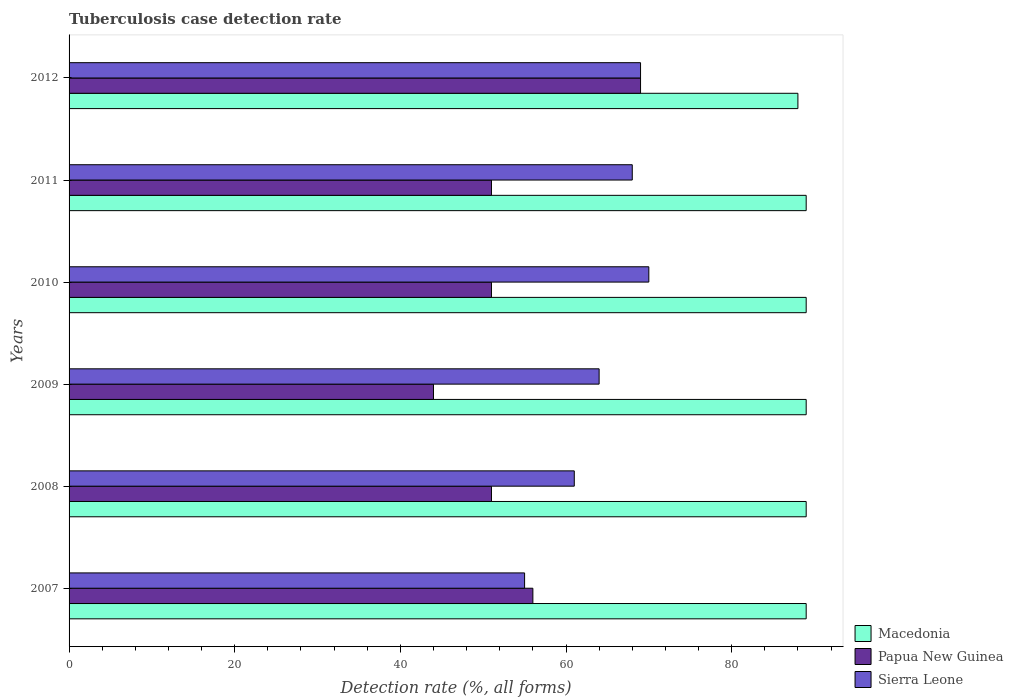Are the number of bars on each tick of the Y-axis equal?
Make the answer very short. Yes. How many bars are there on the 6th tick from the top?
Offer a terse response. 3. How many bars are there on the 2nd tick from the bottom?
Provide a succinct answer. 3. In how many cases, is the number of bars for a given year not equal to the number of legend labels?
Keep it short and to the point. 0. What is the tuberculosis case detection rate in in Sierra Leone in 2011?
Offer a very short reply. 68. Across all years, what is the maximum tuberculosis case detection rate in in Macedonia?
Ensure brevity in your answer.  89. In which year was the tuberculosis case detection rate in in Papua New Guinea maximum?
Offer a terse response. 2012. In which year was the tuberculosis case detection rate in in Papua New Guinea minimum?
Give a very brief answer. 2009. What is the total tuberculosis case detection rate in in Sierra Leone in the graph?
Provide a succinct answer. 387. What is the difference between the tuberculosis case detection rate in in Macedonia in 2007 and that in 2008?
Offer a very short reply. 0. What is the difference between the tuberculosis case detection rate in in Papua New Guinea in 2007 and the tuberculosis case detection rate in in Macedonia in 2012?
Ensure brevity in your answer.  -32. What is the average tuberculosis case detection rate in in Macedonia per year?
Give a very brief answer. 88.83. In the year 2008, what is the difference between the tuberculosis case detection rate in in Sierra Leone and tuberculosis case detection rate in in Macedonia?
Provide a succinct answer. -28. What is the ratio of the tuberculosis case detection rate in in Papua New Guinea in 2009 to that in 2011?
Provide a short and direct response. 0.86. Is the tuberculosis case detection rate in in Sierra Leone in 2008 less than that in 2011?
Provide a succinct answer. Yes. What is the difference between the highest and the lowest tuberculosis case detection rate in in Macedonia?
Provide a short and direct response. 1. In how many years, is the tuberculosis case detection rate in in Papua New Guinea greater than the average tuberculosis case detection rate in in Papua New Guinea taken over all years?
Keep it short and to the point. 2. What does the 3rd bar from the top in 2007 represents?
Make the answer very short. Macedonia. What does the 2nd bar from the bottom in 2011 represents?
Provide a short and direct response. Papua New Guinea. Is it the case that in every year, the sum of the tuberculosis case detection rate in in Macedonia and tuberculosis case detection rate in in Papua New Guinea is greater than the tuberculosis case detection rate in in Sierra Leone?
Your response must be concise. Yes. How many bars are there?
Give a very brief answer. 18. Are all the bars in the graph horizontal?
Your answer should be very brief. Yes. How many years are there in the graph?
Offer a very short reply. 6. What is the difference between two consecutive major ticks on the X-axis?
Your answer should be very brief. 20. Are the values on the major ticks of X-axis written in scientific E-notation?
Make the answer very short. No. How many legend labels are there?
Your answer should be compact. 3. How are the legend labels stacked?
Your response must be concise. Vertical. What is the title of the graph?
Offer a terse response. Tuberculosis case detection rate. What is the label or title of the X-axis?
Your answer should be very brief. Detection rate (%, all forms). What is the Detection rate (%, all forms) of Macedonia in 2007?
Ensure brevity in your answer.  89. What is the Detection rate (%, all forms) in Papua New Guinea in 2007?
Ensure brevity in your answer.  56. What is the Detection rate (%, all forms) in Sierra Leone in 2007?
Provide a short and direct response. 55. What is the Detection rate (%, all forms) of Macedonia in 2008?
Keep it short and to the point. 89. What is the Detection rate (%, all forms) in Papua New Guinea in 2008?
Your answer should be compact. 51. What is the Detection rate (%, all forms) in Sierra Leone in 2008?
Offer a terse response. 61. What is the Detection rate (%, all forms) of Macedonia in 2009?
Keep it short and to the point. 89. What is the Detection rate (%, all forms) in Papua New Guinea in 2009?
Provide a succinct answer. 44. What is the Detection rate (%, all forms) of Macedonia in 2010?
Offer a terse response. 89. What is the Detection rate (%, all forms) in Sierra Leone in 2010?
Offer a very short reply. 70. What is the Detection rate (%, all forms) in Macedonia in 2011?
Provide a short and direct response. 89. What is the Detection rate (%, all forms) in Papua New Guinea in 2011?
Your response must be concise. 51. What is the Detection rate (%, all forms) in Sierra Leone in 2011?
Keep it short and to the point. 68. What is the Detection rate (%, all forms) in Papua New Guinea in 2012?
Give a very brief answer. 69. Across all years, what is the maximum Detection rate (%, all forms) in Macedonia?
Make the answer very short. 89. Across all years, what is the maximum Detection rate (%, all forms) of Papua New Guinea?
Your answer should be compact. 69. Across all years, what is the maximum Detection rate (%, all forms) in Sierra Leone?
Ensure brevity in your answer.  70. Across all years, what is the minimum Detection rate (%, all forms) in Macedonia?
Offer a very short reply. 88. Across all years, what is the minimum Detection rate (%, all forms) of Papua New Guinea?
Provide a short and direct response. 44. Across all years, what is the minimum Detection rate (%, all forms) of Sierra Leone?
Your response must be concise. 55. What is the total Detection rate (%, all forms) of Macedonia in the graph?
Provide a short and direct response. 533. What is the total Detection rate (%, all forms) in Papua New Guinea in the graph?
Give a very brief answer. 322. What is the total Detection rate (%, all forms) of Sierra Leone in the graph?
Ensure brevity in your answer.  387. What is the difference between the Detection rate (%, all forms) in Macedonia in 2007 and that in 2008?
Your answer should be compact. 0. What is the difference between the Detection rate (%, all forms) of Papua New Guinea in 2007 and that in 2008?
Your answer should be compact. 5. What is the difference between the Detection rate (%, all forms) of Sierra Leone in 2007 and that in 2009?
Your answer should be very brief. -9. What is the difference between the Detection rate (%, all forms) in Papua New Guinea in 2007 and that in 2010?
Provide a succinct answer. 5. What is the difference between the Detection rate (%, all forms) in Sierra Leone in 2007 and that in 2011?
Provide a short and direct response. -13. What is the difference between the Detection rate (%, all forms) of Macedonia in 2007 and that in 2012?
Provide a succinct answer. 1. What is the difference between the Detection rate (%, all forms) in Papua New Guinea in 2007 and that in 2012?
Provide a short and direct response. -13. What is the difference between the Detection rate (%, all forms) of Sierra Leone in 2007 and that in 2012?
Provide a succinct answer. -14. What is the difference between the Detection rate (%, all forms) of Macedonia in 2008 and that in 2009?
Provide a succinct answer. 0. What is the difference between the Detection rate (%, all forms) in Papua New Guinea in 2008 and that in 2009?
Offer a terse response. 7. What is the difference between the Detection rate (%, all forms) in Macedonia in 2008 and that in 2010?
Give a very brief answer. 0. What is the difference between the Detection rate (%, all forms) in Papua New Guinea in 2008 and that in 2010?
Make the answer very short. 0. What is the difference between the Detection rate (%, all forms) in Sierra Leone in 2008 and that in 2010?
Keep it short and to the point. -9. What is the difference between the Detection rate (%, all forms) in Papua New Guinea in 2008 and that in 2011?
Give a very brief answer. 0. What is the difference between the Detection rate (%, all forms) of Macedonia in 2008 and that in 2012?
Provide a succinct answer. 1. What is the difference between the Detection rate (%, all forms) of Macedonia in 2009 and that in 2010?
Ensure brevity in your answer.  0. What is the difference between the Detection rate (%, all forms) in Papua New Guinea in 2009 and that in 2010?
Make the answer very short. -7. What is the difference between the Detection rate (%, all forms) of Sierra Leone in 2009 and that in 2010?
Provide a short and direct response. -6. What is the difference between the Detection rate (%, all forms) of Macedonia in 2009 and that in 2011?
Provide a succinct answer. 0. What is the difference between the Detection rate (%, all forms) of Papua New Guinea in 2009 and that in 2011?
Make the answer very short. -7. What is the difference between the Detection rate (%, all forms) of Macedonia in 2010 and that in 2011?
Make the answer very short. 0. What is the difference between the Detection rate (%, all forms) in Macedonia in 2010 and that in 2012?
Make the answer very short. 1. What is the difference between the Detection rate (%, all forms) in Sierra Leone in 2010 and that in 2012?
Your answer should be compact. 1. What is the difference between the Detection rate (%, all forms) of Papua New Guinea in 2011 and that in 2012?
Provide a succinct answer. -18. What is the difference between the Detection rate (%, all forms) in Sierra Leone in 2011 and that in 2012?
Your answer should be compact. -1. What is the difference between the Detection rate (%, all forms) of Macedonia in 2007 and the Detection rate (%, all forms) of Papua New Guinea in 2008?
Your answer should be compact. 38. What is the difference between the Detection rate (%, all forms) of Papua New Guinea in 2007 and the Detection rate (%, all forms) of Sierra Leone in 2008?
Provide a succinct answer. -5. What is the difference between the Detection rate (%, all forms) in Macedonia in 2007 and the Detection rate (%, all forms) in Sierra Leone in 2009?
Keep it short and to the point. 25. What is the difference between the Detection rate (%, all forms) in Macedonia in 2007 and the Detection rate (%, all forms) in Papua New Guinea in 2011?
Provide a succinct answer. 38. What is the difference between the Detection rate (%, all forms) in Macedonia in 2007 and the Detection rate (%, all forms) in Sierra Leone in 2011?
Keep it short and to the point. 21. What is the difference between the Detection rate (%, all forms) of Papua New Guinea in 2007 and the Detection rate (%, all forms) of Sierra Leone in 2011?
Your response must be concise. -12. What is the difference between the Detection rate (%, all forms) in Macedonia in 2007 and the Detection rate (%, all forms) in Papua New Guinea in 2012?
Make the answer very short. 20. What is the difference between the Detection rate (%, all forms) of Macedonia in 2007 and the Detection rate (%, all forms) of Sierra Leone in 2012?
Keep it short and to the point. 20. What is the difference between the Detection rate (%, all forms) of Papua New Guinea in 2007 and the Detection rate (%, all forms) of Sierra Leone in 2012?
Provide a short and direct response. -13. What is the difference between the Detection rate (%, all forms) in Macedonia in 2008 and the Detection rate (%, all forms) in Papua New Guinea in 2009?
Your answer should be compact. 45. What is the difference between the Detection rate (%, all forms) of Macedonia in 2008 and the Detection rate (%, all forms) of Sierra Leone in 2009?
Make the answer very short. 25. What is the difference between the Detection rate (%, all forms) of Macedonia in 2008 and the Detection rate (%, all forms) of Papua New Guinea in 2010?
Provide a short and direct response. 38. What is the difference between the Detection rate (%, all forms) in Papua New Guinea in 2008 and the Detection rate (%, all forms) in Sierra Leone in 2010?
Make the answer very short. -19. What is the difference between the Detection rate (%, all forms) in Papua New Guinea in 2008 and the Detection rate (%, all forms) in Sierra Leone in 2011?
Provide a succinct answer. -17. What is the difference between the Detection rate (%, all forms) in Macedonia in 2008 and the Detection rate (%, all forms) in Papua New Guinea in 2012?
Your answer should be compact. 20. What is the difference between the Detection rate (%, all forms) in Macedonia in 2008 and the Detection rate (%, all forms) in Sierra Leone in 2012?
Offer a very short reply. 20. What is the difference between the Detection rate (%, all forms) in Papua New Guinea in 2008 and the Detection rate (%, all forms) in Sierra Leone in 2012?
Your answer should be very brief. -18. What is the difference between the Detection rate (%, all forms) of Macedonia in 2009 and the Detection rate (%, all forms) of Papua New Guinea in 2010?
Your answer should be compact. 38. What is the difference between the Detection rate (%, all forms) in Macedonia in 2009 and the Detection rate (%, all forms) in Sierra Leone in 2010?
Offer a very short reply. 19. What is the difference between the Detection rate (%, all forms) of Macedonia in 2009 and the Detection rate (%, all forms) of Sierra Leone in 2011?
Keep it short and to the point. 21. What is the difference between the Detection rate (%, all forms) in Papua New Guinea in 2009 and the Detection rate (%, all forms) in Sierra Leone in 2011?
Keep it short and to the point. -24. What is the difference between the Detection rate (%, all forms) of Macedonia in 2009 and the Detection rate (%, all forms) of Papua New Guinea in 2012?
Your response must be concise. 20. What is the difference between the Detection rate (%, all forms) in Macedonia in 2009 and the Detection rate (%, all forms) in Sierra Leone in 2012?
Offer a terse response. 20. What is the difference between the Detection rate (%, all forms) of Macedonia in 2010 and the Detection rate (%, all forms) of Papua New Guinea in 2011?
Your answer should be very brief. 38. What is the difference between the Detection rate (%, all forms) of Macedonia in 2010 and the Detection rate (%, all forms) of Sierra Leone in 2011?
Give a very brief answer. 21. What is the difference between the Detection rate (%, all forms) of Macedonia in 2010 and the Detection rate (%, all forms) of Sierra Leone in 2012?
Ensure brevity in your answer.  20. What is the difference between the Detection rate (%, all forms) in Macedonia in 2011 and the Detection rate (%, all forms) in Papua New Guinea in 2012?
Provide a succinct answer. 20. What is the average Detection rate (%, all forms) in Macedonia per year?
Keep it short and to the point. 88.83. What is the average Detection rate (%, all forms) of Papua New Guinea per year?
Your response must be concise. 53.67. What is the average Detection rate (%, all forms) in Sierra Leone per year?
Give a very brief answer. 64.5. In the year 2007, what is the difference between the Detection rate (%, all forms) in Macedonia and Detection rate (%, all forms) in Papua New Guinea?
Your answer should be compact. 33. In the year 2007, what is the difference between the Detection rate (%, all forms) in Macedonia and Detection rate (%, all forms) in Sierra Leone?
Provide a short and direct response. 34. In the year 2008, what is the difference between the Detection rate (%, all forms) of Macedonia and Detection rate (%, all forms) of Papua New Guinea?
Offer a terse response. 38. In the year 2008, what is the difference between the Detection rate (%, all forms) in Macedonia and Detection rate (%, all forms) in Sierra Leone?
Your answer should be compact. 28. In the year 2008, what is the difference between the Detection rate (%, all forms) of Papua New Guinea and Detection rate (%, all forms) of Sierra Leone?
Make the answer very short. -10. In the year 2009, what is the difference between the Detection rate (%, all forms) in Macedonia and Detection rate (%, all forms) in Sierra Leone?
Your response must be concise. 25. In the year 2009, what is the difference between the Detection rate (%, all forms) in Papua New Guinea and Detection rate (%, all forms) in Sierra Leone?
Make the answer very short. -20. In the year 2010, what is the difference between the Detection rate (%, all forms) of Macedonia and Detection rate (%, all forms) of Papua New Guinea?
Offer a terse response. 38. In the year 2010, what is the difference between the Detection rate (%, all forms) of Macedonia and Detection rate (%, all forms) of Sierra Leone?
Your answer should be compact. 19. In the year 2011, what is the difference between the Detection rate (%, all forms) of Macedonia and Detection rate (%, all forms) of Papua New Guinea?
Your response must be concise. 38. In the year 2011, what is the difference between the Detection rate (%, all forms) of Papua New Guinea and Detection rate (%, all forms) of Sierra Leone?
Keep it short and to the point. -17. In the year 2012, what is the difference between the Detection rate (%, all forms) in Macedonia and Detection rate (%, all forms) in Papua New Guinea?
Your answer should be compact. 19. In the year 2012, what is the difference between the Detection rate (%, all forms) in Macedonia and Detection rate (%, all forms) in Sierra Leone?
Offer a terse response. 19. In the year 2012, what is the difference between the Detection rate (%, all forms) in Papua New Guinea and Detection rate (%, all forms) in Sierra Leone?
Ensure brevity in your answer.  0. What is the ratio of the Detection rate (%, all forms) in Papua New Guinea in 2007 to that in 2008?
Make the answer very short. 1.1. What is the ratio of the Detection rate (%, all forms) of Sierra Leone in 2007 to that in 2008?
Your answer should be very brief. 0.9. What is the ratio of the Detection rate (%, all forms) of Papua New Guinea in 2007 to that in 2009?
Ensure brevity in your answer.  1.27. What is the ratio of the Detection rate (%, all forms) of Sierra Leone in 2007 to that in 2009?
Make the answer very short. 0.86. What is the ratio of the Detection rate (%, all forms) of Papua New Guinea in 2007 to that in 2010?
Make the answer very short. 1.1. What is the ratio of the Detection rate (%, all forms) in Sierra Leone in 2007 to that in 2010?
Your answer should be compact. 0.79. What is the ratio of the Detection rate (%, all forms) in Papua New Guinea in 2007 to that in 2011?
Provide a short and direct response. 1.1. What is the ratio of the Detection rate (%, all forms) of Sierra Leone in 2007 to that in 2011?
Give a very brief answer. 0.81. What is the ratio of the Detection rate (%, all forms) in Macedonia in 2007 to that in 2012?
Give a very brief answer. 1.01. What is the ratio of the Detection rate (%, all forms) of Papua New Guinea in 2007 to that in 2012?
Offer a very short reply. 0.81. What is the ratio of the Detection rate (%, all forms) in Sierra Leone in 2007 to that in 2012?
Make the answer very short. 0.8. What is the ratio of the Detection rate (%, all forms) of Macedonia in 2008 to that in 2009?
Give a very brief answer. 1. What is the ratio of the Detection rate (%, all forms) of Papua New Guinea in 2008 to that in 2009?
Provide a succinct answer. 1.16. What is the ratio of the Detection rate (%, all forms) in Sierra Leone in 2008 to that in 2009?
Keep it short and to the point. 0.95. What is the ratio of the Detection rate (%, all forms) in Sierra Leone in 2008 to that in 2010?
Give a very brief answer. 0.87. What is the ratio of the Detection rate (%, all forms) in Sierra Leone in 2008 to that in 2011?
Your answer should be compact. 0.9. What is the ratio of the Detection rate (%, all forms) in Macedonia in 2008 to that in 2012?
Your response must be concise. 1.01. What is the ratio of the Detection rate (%, all forms) in Papua New Guinea in 2008 to that in 2012?
Your answer should be compact. 0.74. What is the ratio of the Detection rate (%, all forms) in Sierra Leone in 2008 to that in 2012?
Offer a very short reply. 0.88. What is the ratio of the Detection rate (%, all forms) in Macedonia in 2009 to that in 2010?
Your response must be concise. 1. What is the ratio of the Detection rate (%, all forms) of Papua New Guinea in 2009 to that in 2010?
Offer a terse response. 0.86. What is the ratio of the Detection rate (%, all forms) of Sierra Leone in 2009 to that in 2010?
Offer a terse response. 0.91. What is the ratio of the Detection rate (%, all forms) in Papua New Guinea in 2009 to that in 2011?
Ensure brevity in your answer.  0.86. What is the ratio of the Detection rate (%, all forms) of Sierra Leone in 2009 to that in 2011?
Keep it short and to the point. 0.94. What is the ratio of the Detection rate (%, all forms) in Macedonia in 2009 to that in 2012?
Make the answer very short. 1.01. What is the ratio of the Detection rate (%, all forms) in Papua New Guinea in 2009 to that in 2012?
Offer a very short reply. 0.64. What is the ratio of the Detection rate (%, all forms) of Sierra Leone in 2009 to that in 2012?
Your response must be concise. 0.93. What is the ratio of the Detection rate (%, all forms) of Macedonia in 2010 to that in 2011?
Your answer should be very brief. 1. What is the ratio of the Detection rate (%, all forms) in Papua New Guinea in 2010 to that in 2011?
Keep it short and to the point. 1. What is the ratio of the Detection rate (%, all forms) of Sierra Leone in 2010 to that in 2011?
Keep it short and to the point. 1.03. What is the ratio of the Detection rate (%, all forms) of Macedonia in 2010 to that in 2012?
Offer a very short reply. 1.01. What is the ratio of the Detection rate (%, all forms) in Papua New Guinea in 2010 to that in 2012?
Your response must be concise. 0.74. What is the ratio of the Detection rate (%, all forms) in Sierra Leone in 2010 to that in 2012?
Provide a succinct answer. 1.01. What is the ratio of the Detection rate (%, all forms) of Macedonia in 2011 to that in 2012?
Give a very brief answer. 1.01. What is the ratio of the Detection rate (%, all forms) in Papua New Guinea in 2011 to that in 2012?
Your response must be concise. 0.74. What is the ratio of the Detection rate (%, all forms) of Sierra Leone in 2011 to that in 2012?
Offer a very short reply. 0.99. What is the difference between the highest and the second highest Detection rate (%, all forms) in Papua New Guinea?
Your answer should be compact. 13. What is the difference between the highest and the lowest Detection rate (%, all forms) of Macedonia?
Give a very brief answer. 1. 